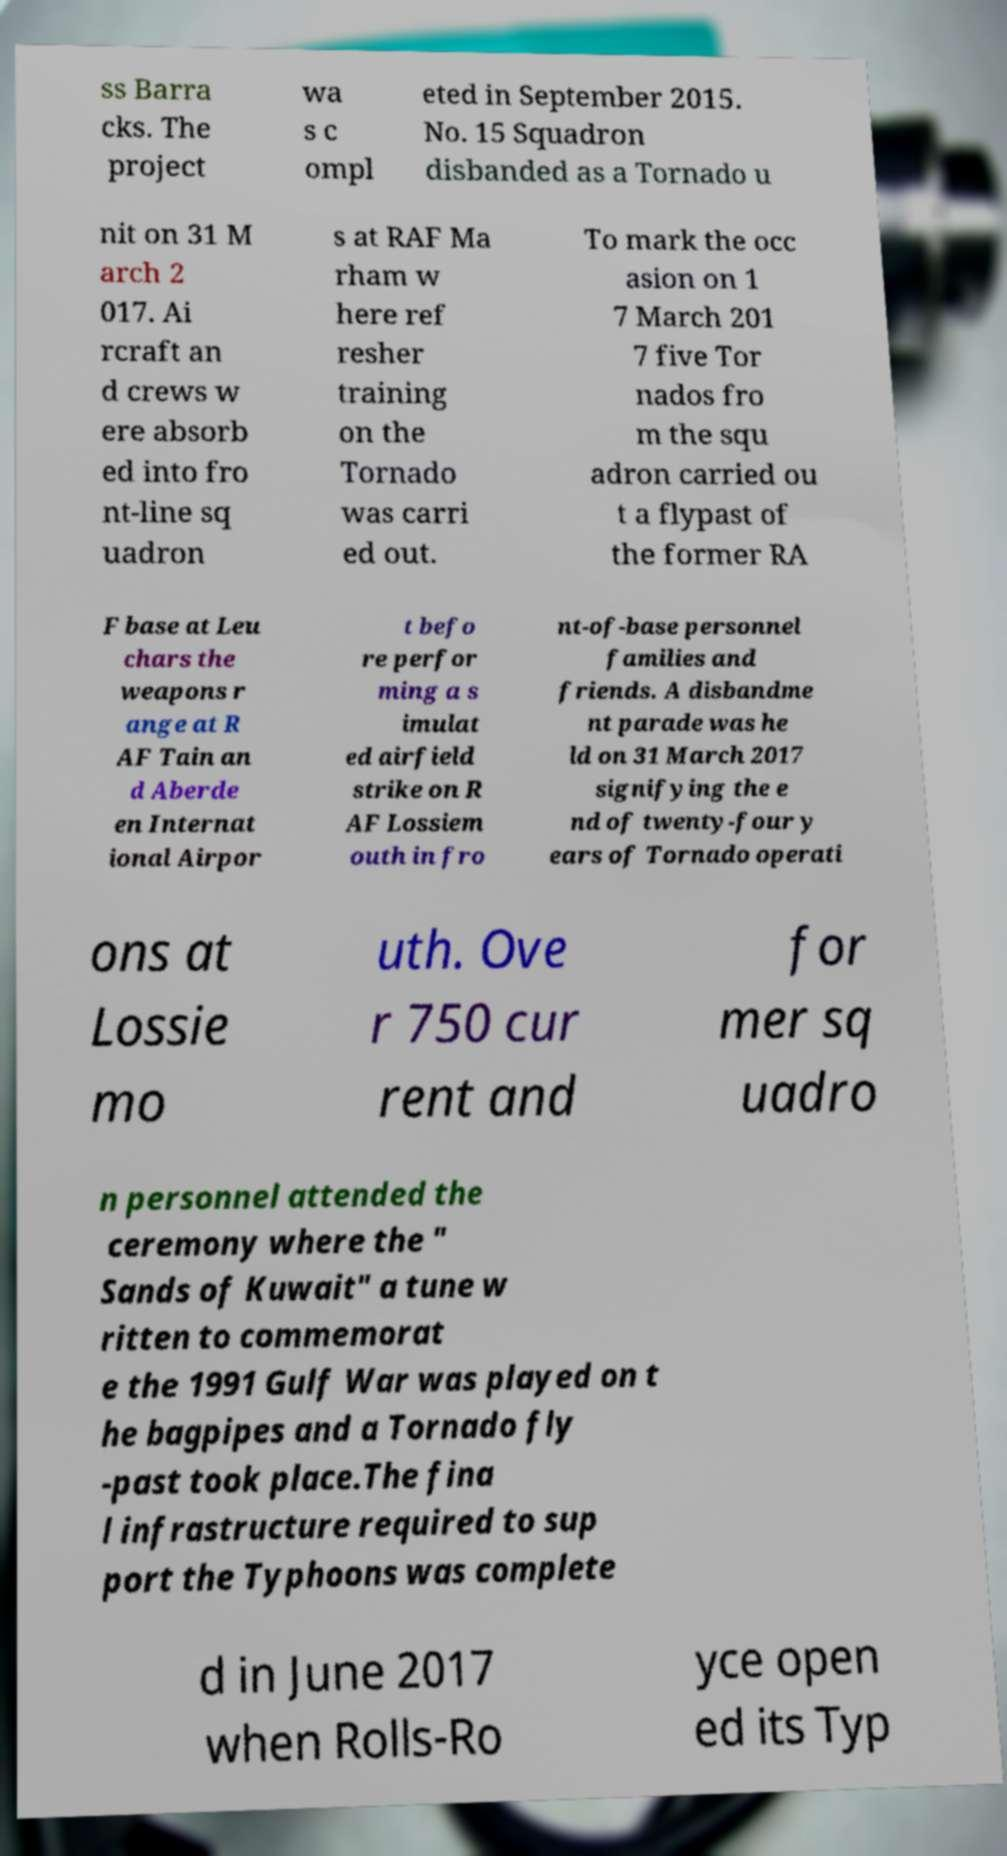For documentation purposes, I need the text within this image transcribed. Could you provide that? ss Barra cks. The project wa s c ompl eted in September 2015. No. 15 Squadron disbanded as a Tornado u nit on 31 M arch 2 017. Ai rcraft an d crews w ere absorb ed into fro nt-line sq uadron s at RAF Ma rham w here ref resher training on the Tornado was carri ed out. To mark the occ asion on 1 7 March 201 7 five Tor nados fro m the squ adron carried ou t a flypast of the former RA F base at Leu chars the weapons r ange at R AF Tain an d Aberde en Internat ional Airpor t befo re perfor ming a s imulat ed airfield strike on R AF Lossiem outh in fro nt-of-base personnel families and friends. A disbandme nt parade was he ld on 31 March 2017 signifying the e nd of twenty-four y ears of Tornado operati ons at Lossie mo uth. Ove r 750 cur rent and for mer sq uadro n personnel attended the ceremony where the " Sands of Kuwait" a tune w ritten to commemorat e the 1991 Gulf War was played on t he bagpipes and a Tornado fly -past took place.The fina l infrastructure required to sup port the Typhoons was complete d in June 2017 when Rolls-Ro yce open ed its Typ 